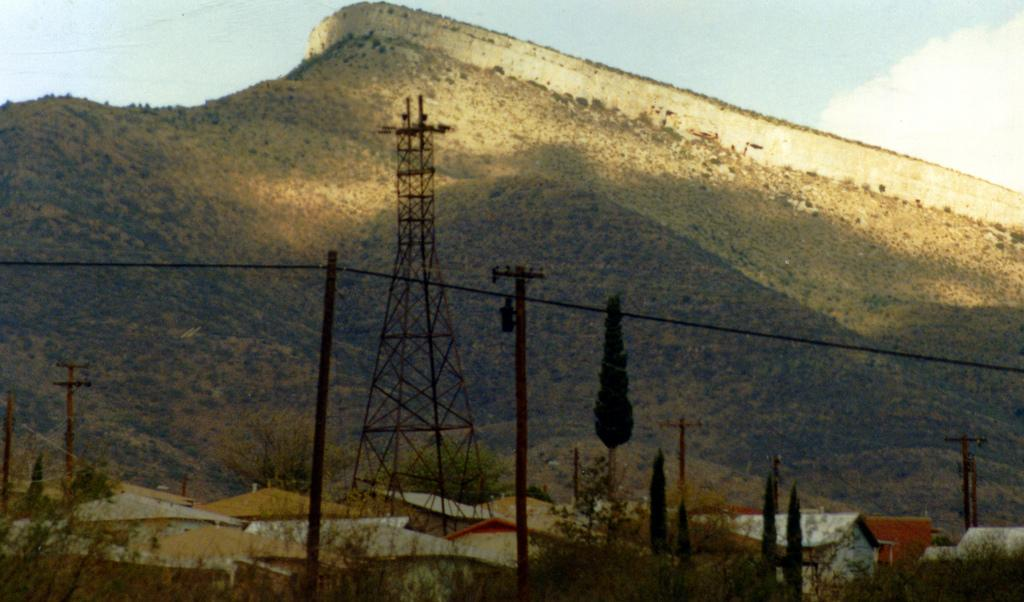What type of structures can be seen in the image? There are houses, a tower, and a wall visible in the image. What natural elements are present in the image? There are trees and mountains in the image. What man-made objects can be seen in the image? There are poles in the image. What is visible in the sky in the image? The sky is visible in the image, and clouds are present. What type of statement can be seen written on the wall in the image? There is no statement visible on the wall in the image. Can you identify any insects present in the image? There are no insects present in the image. 